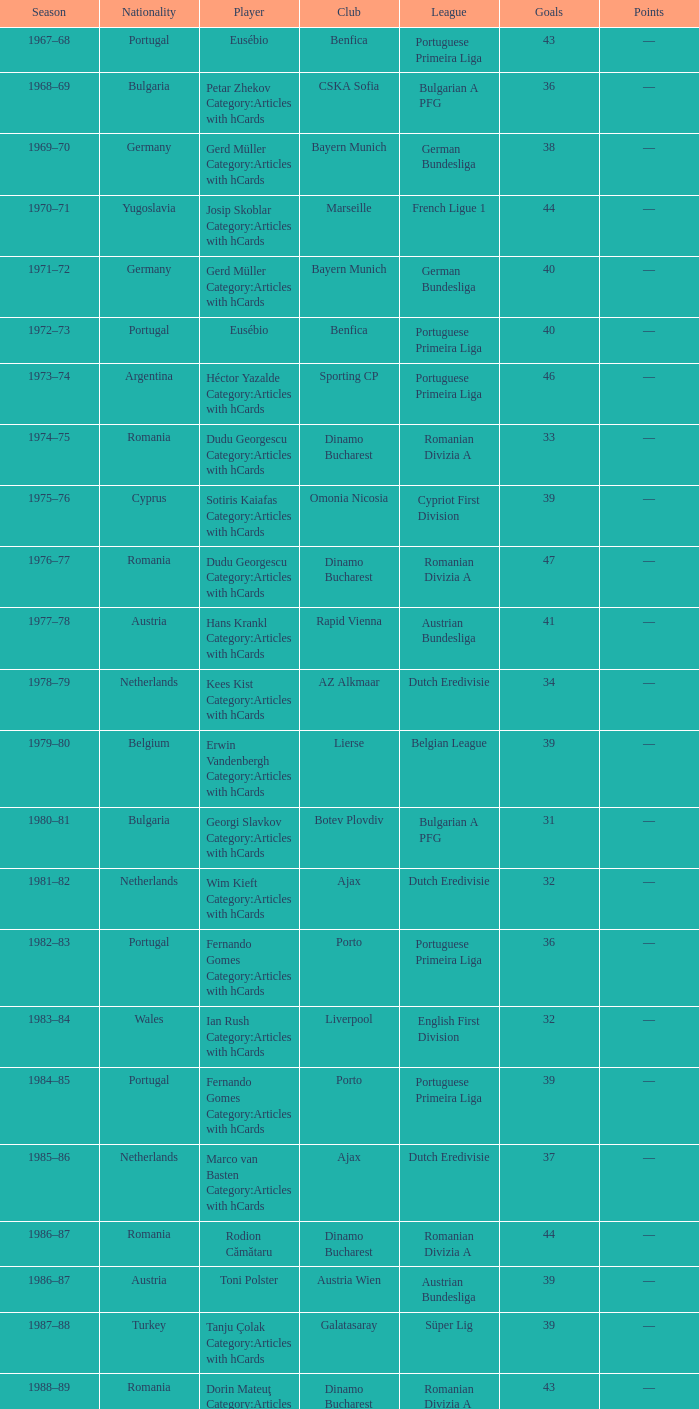Can you parse all the data within this table? {'header': ['Season', 'Nationality', 'Player', 'Club', 'League', 'Goals', 'Points'], 'rows': [['1967–68', 'Portugal', 'Eusébio', 'Benfica', 'Portuguese Primeira Liga', '43', '—'], ['1968–69', 'Bulgaria', 'Petar Zhekov Category:Articles with hCards', 'CSKA Sofia', 'Bulgarian A PFG', '36', '—'], ['1969–70', 'Germany', 'Gerd Müller Category:Articles with hCards', 'Bayern Munich', 'German Bundesliga', '38', '—'], ['1970–71', 'Yugoslavia', 'Josip Skoblar Category:Articles with hCards', 'Marseille', 'French Ligue 1', '44', '—'], ['1971–72', 'Germany', 'Gerd Müller Category:Articles with hCards', 'Bayern Munich', 'German Bundesliga', '40', '—'], ['1972–73', 'Portugal', 'Eusébio', 'Benfica', 'Portuguese Primeira Liga', '40', '—'], ['1973–74', 'Argentina', 'Héctor Yazalde Category:Articles with hCards', 'Sporting CP', 'Portuguese Primeira Liga', '46', '—'], ['1974–75', 'Romania', 'Dudu Georgescu Category:Articles with hCards', 'Dinamo Bucharest', 'Romanian Divizia A', '33', '—'], ['1975–76', 'Cyprus', 'Sotiris Kaiafas Category:Articles with hCards', 'Omonia Nicosia', 'Cypriot First Division', '39', '—'], ['1976–77', 'Romania', 'Dudu Georgescu Category:Articles with hCards', 'Dinamo Bucharest', 'Romanian Divizia A', '47', '—'], ['1977–78', 'Austria', 'Hans Krankl Category:Articles with hCards', 'Rapid Vienna', 'Austrian Bundesliga', '41', '—'], ['1978–79', 'Netherlands', 'Kees Kist Category:Articles with hCards', 'AZ Alkmaar', 'Dutch Eredivisie', '34', '—'], ['1979–80', 'Belgium', 'Erwin Vandenbergh Category:Articles with hCards', 'Lierse', 'Belgian League', '39', '—'], ['1980–81', 'Bulgaria', 'Georgi Slavkov Category:Articles with hCards', 'Botev Plovdiv', 'Bulgarian A PFG', '31', '—'], ['1981–82', 'Netherlands', 'Wim Kieft Category:Articles with hCards', 'Ajax', 'Dutch Eredivisie', '32', '—'], ['1982–83', 'Portugal', 'Fernando Gomes Category:Articles with hCards', 'Porto', 'Portuguese Primeira Liga', '36', '—'], ['1983–84', 'Wales', 'Ian Rush Category:Articles with hCards', 'Liverpool', 'English First Division', '32', '—'], ['1984–85', 'Portugal', 'Fernando Gomes Category:Articles with hCards', 'Porto', 'Portuguese Primeira Liga', '39', '—'], ['1985–86', 'Netherlands', 'Marco van Basten Category:Articles with hCards', 'Ajax', 'Dutch Eredivisie', '37', '—'], ['1986–87', 'Romania', 'Rodion Cămătaru', 'Dinamo Bucharest', 'Romanian Divizia A', '44', '—'], ['1986–87', 'Austria', 'Toni Polster', 'Austria Wien', 'Austrian Bundesliga', '39', '—'], ['1987–88', 'Turkey', 'Tanju Çolak Category:Articles with hCards', 'Galatasaray', 'Süper Lig', '39', '—'], ['1988–89', 'Romania', 'Dorin Mateuţ Category:Articles with hCards', 'Dinamo Bucharest', 'Romanian Divizia A', '43', '—'], ['1989–90', 'Mexico', 'Hugo Sánchez Category:Articles with hCards', 'Real Madrid', 'Spanish La Liga', '38', '—'], ['1989–90', 'Bulgaria', 'Hristo Stoichkov Category:Articles with hCards', 'CSKA Sofia', 'Bulgarian A PFG', '38', '—'], ['1990–91', 'Yugoslavia', 'Darko Pančev Category:Articles with hCards', 'Red Star', 'Yugoslav First League', '34', '—'], ['1991–92', 'Scotland', 'Ally McCoist Category:Articles with hCards', 'Rangers', 'Scottish Premier Division', '34', '—'], ['1992–93', 'Scotland', 'Ally McCoist Category:Articles with hCards', 'Rangers', 'Scottish Premier Division', '34', '—'], ['1993–94', 'Wales', 'David Taylor Category:Articles with hCards', 'Porthmadog', 'League of Wales', '43', '—'], ['1994–95', 'Armenia', 'Arsen Avetisyan Category:Articles with hCards', 'Homenetmen', 'Armenian Premier League', '39', '—'], ['1995–96', 'Georgia', 'Zviad Endeladze Category:Articles with hCards', 'Margveti', 'Georgian Umaglesi Liga', '40', '—'], ['1996–97', 'Brazil', 'Ronaldo', 'Barcelona', 'Spanish La Liga', '34', '68'], ['1997–98', 'Greece', 'Nikos Machlas Category:Articles with hCards', 'Vitesse', 'Dutch Eredivisie', '34', '68'], ['1998–99', 'Brazil', 'Mário Jardel Category:Articles with hCards', 'Porto', 'Portuguese Primeira Liga', '36', '72'], ['1999–2000', 'England', 'Kevin Phillips Category:Articles with hCards', 'Sunderland', 'English Premier League', '30', '60'], ['2000–01', 'Sweden', 'Henrik Larsson Category:Articles with hCards', 'Celtic', 'Scottish Premier League', '35', '52.5'], ['2001–02', 'Brazil', 'Mário Jardel Category:Articles with hCards', 'Sporting CP', 'Portuguese Primeira Liga', '42', '84'], ['2002–03', 'Netherlands', 'Roy Makaay Category:Articles with hCards', 'Deportivo La Coruña', 'Spanish La Liga', '29', '58'], ['2003–04', 'France', 'Thierry Henry Category:Articles with hCards', 'Arsenal', 'English Premier League', '30', '60'], ['2004–05', 'France', 'Thierry Henry Category:Articles with hCards', 'Arsenal', 'English Premier League', '25', '50'], ['2004–05', 'Uruguay', 'Diego Forlán Category:Articles with hCards', 'Villarreal', 'Spanish La Liga', '25', '50'], ['2005–06', 'Italy', 'Luca Toni Category:Articles with hCards', 'Fiorentina', 'Italian Serie A', '31', '62'], ['2006–07', 'Italy', 'Francesco Totti Category:Articles with hCards', 'Roma', 'Italian Serie A', '26', '52'], ['2007–08', 'Portugal', 'Cristiano Ronaldo Category:Articles with hCards', 'Manchester United', 'English Premier League', '31', '62'], ['2008–09', 'Uruguay', 'Diego Forlán Category:Articles with hCards', 'Atlético Madrid', 'Spanish La Liga', '32', '64'], ['2009–10', 'Argentina', 'Lionel Messi Category:Articles with hCards', 'Barcelona', 'Spanish La Liga', '34', '68'], ['2010–11', 'Portugal', 'Cristiano Ronaldo Category:Articles with hCards', 'Real Madrid', 'Spanish La Liga', '40', '80'], ['2011–12', 'Argentina', 'Lionel Messi Category:Articles with hCards', 'Barcelona', 'Spanish La Liga', '50', '100'], ['2012–13', 'Argentina', 'Lionel Messi Category:Articles with hCards', 'Barcelona', 'Spanish La Liga', '46', '92']]} Which league's nationality was Italy when there were 62 points? Italian Serie A. 